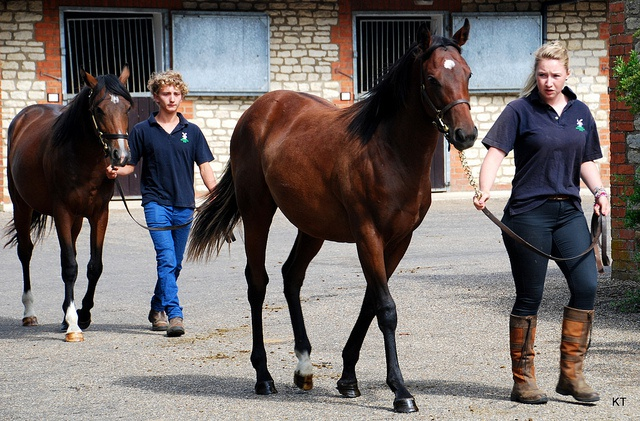Describe the objects in this image and their specific colors. I can see horse in black, maroon, brown, and gray tones, people in black, navy, gray, and lightgray tones, horse in black, maroon, gray, and darkgray tones, and people in black, navy, and blue tones in this image. 